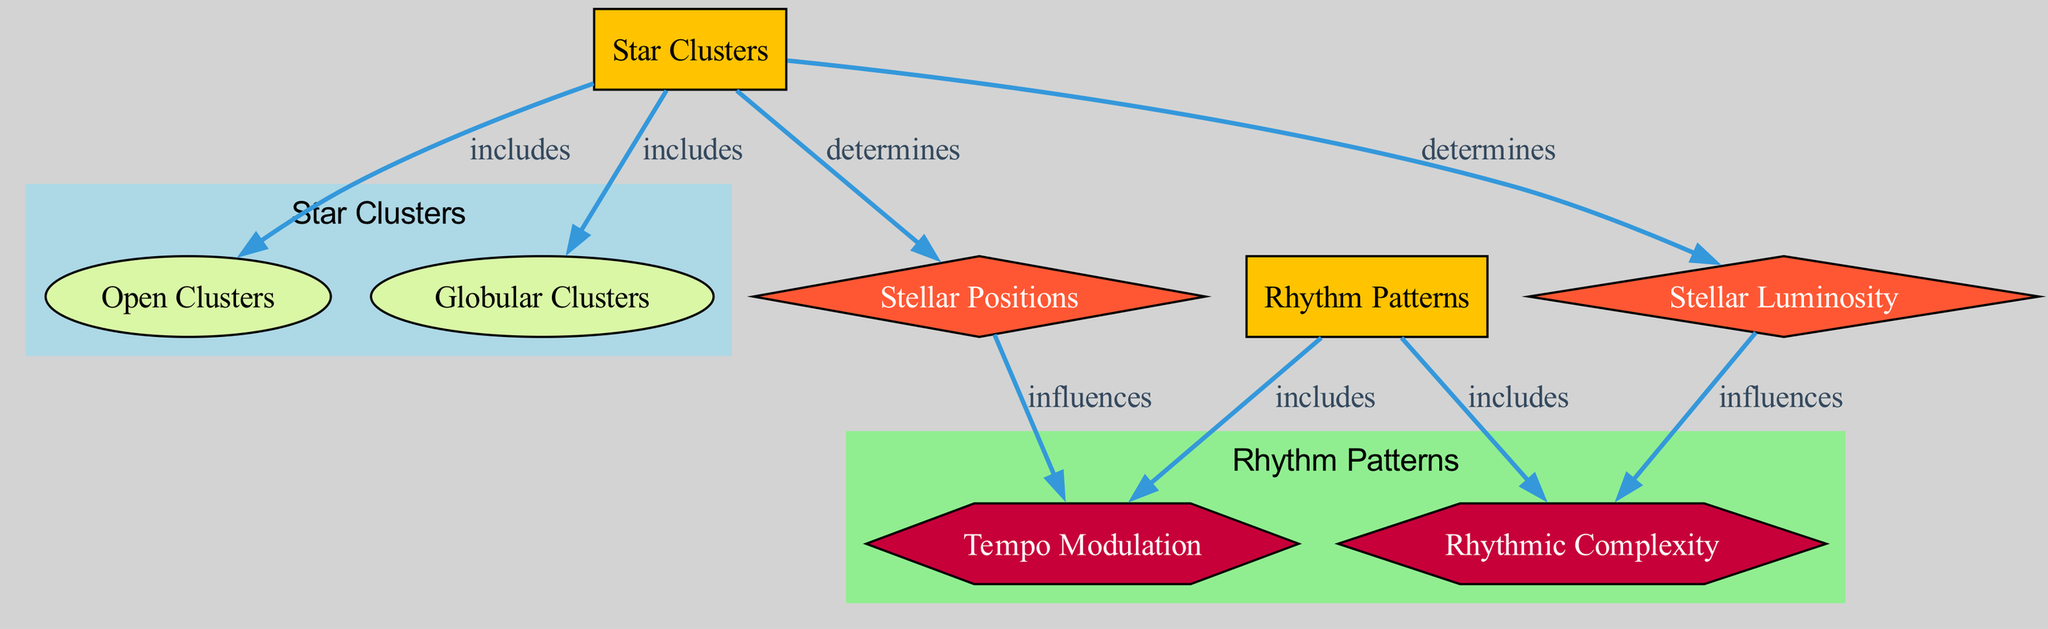What are the two types of star clusters included in the diagram? The diagram highlights two sub-categories of star clusters: "Open Clusters" and "Globular Clusters." These are direct nodes connected under the main category of "Star Clusters."
Answer: Open Clusters, Globular Clusters How many nodes are present in the diagram? By counting the distinct nodes listed in the diagram, we find there are a total of seven nodes: "Star Clusters," "Open Clusters," "Globular Clusters," "Rhythm Patterns," "Stellar Positions," "Stellar Luminosity," "Tempo Modulation," and "Rhythmic Complexity."
Answer: 7 What type of relationship exists between "Star Clusters" and "Stellar Positions"? The diagram shows that "Star Clusters" determines "Stellar Positions," indicating a directional relationship where the attributes of star clusters influence stellar positions.
Answer: determines Which aspect is influenced by "Stellar Positions"? The diagram specifies that "Tempo Modulation" is influenced by "Stellar Positions," connecting the feature of stellar positioning with the dynamic alteration of tempo.
Answer: Tempo Modulation What influences "Rhythmic Complexity"? In the diagram, "Rhythmic Complexity" is influenced by "Stellar Luminosity," indicating a relationship where the brightness of stars affects the complexity of rhythmic patterns.
Answer: Stellar Luminosity How many types of aspects are included in the rhythm patterns category? The "Rhythm Patterns" category includes two aspects: "Tempo Modulation" and "Rhythmic Complexity," both of which are critical in analyzing rhythm structures.
Answer: 2 What is the primary relationship direction from "Star Clusters" to "Rhythm Patterns"? The primary relationship direction from "Star Clusters" is one of determination regarding the features, indicating that attributes of star clusters likely influence rhythm patterns through their characteristics, though not shown directly in the diagram as an edge.
Answer: None What type of node is "Stellar Luminosity"? The diagram categorizes "Stellar Luminosity" as a feature node, as indicated by its shape (a diamond) and placement within the context of influences on other aspects such as rhythmic complexity.
Answer: feature 